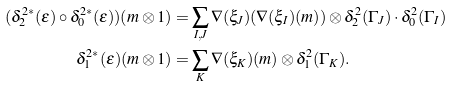<formula> <loc_0><loc_0><loc_500><loc_500>( \delta ^ { 2 * } _ { 2 } ( \epsilon ) \circ \delta ^ { 2 * } _ { 0 } ( \epsilon ) ) ( m \otimes 1 ) & = \sum _ { I , J } \nabla ( \xi _ { J } ) ( \nabla ( \xi _ { I } ) ( m ) ) \otimes \delta ^ { 2 } _ { 2 } ( \Gamma _ { J } ) \cdot \delta ^ { 2 } _ { 0 } ( \Gamma _ { I } ) \\ \delta ^ { 2 * } _ { 1 } ( \epsilon ) ( m \otimes 1 ) & = \sum _ { K } \nabla ( \xi _ { K } ) ( m ) \otimes \delta ^ { 2 } _ { 1 } ( \Gamma _ { K } ) .</formula> 